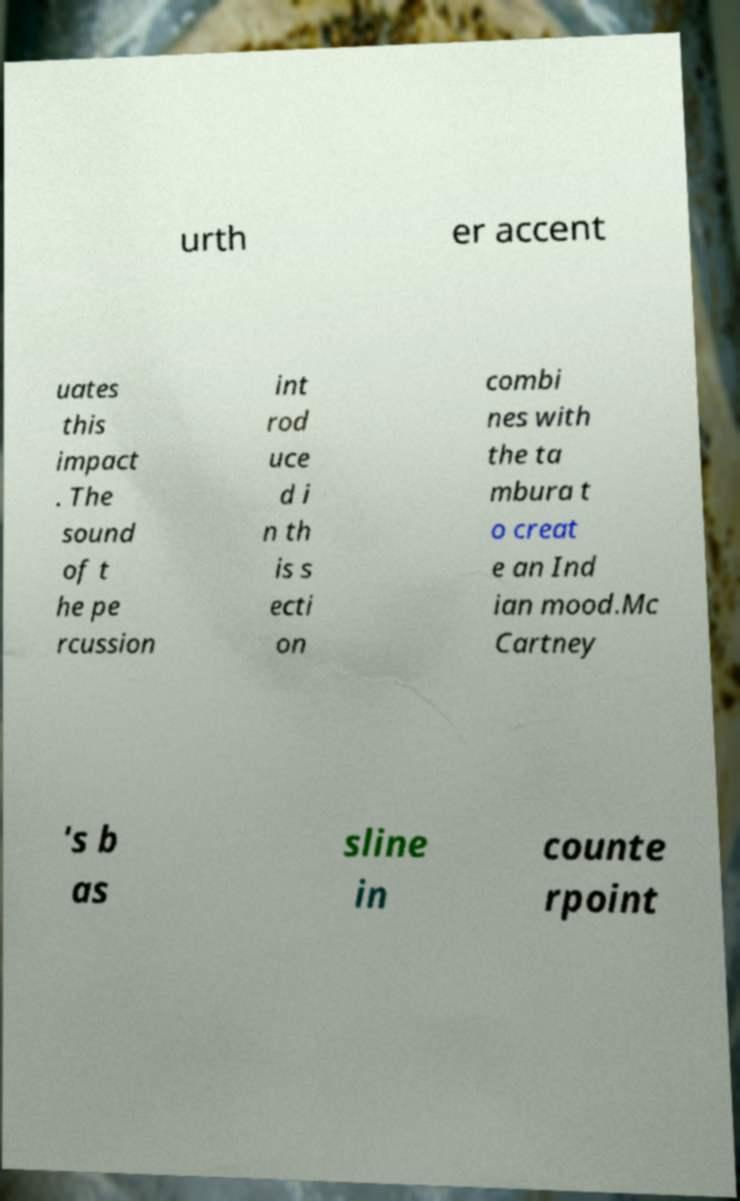Please identify and transcribe the text found in this image. urth er accent uates this impact . The sound of t he pe rcussion int rod uce d i n th is s ecti on combi nes with the ta mbura t o creat e an Ind ian mood.Mc Cartney 's b as sline in counte rpoint 